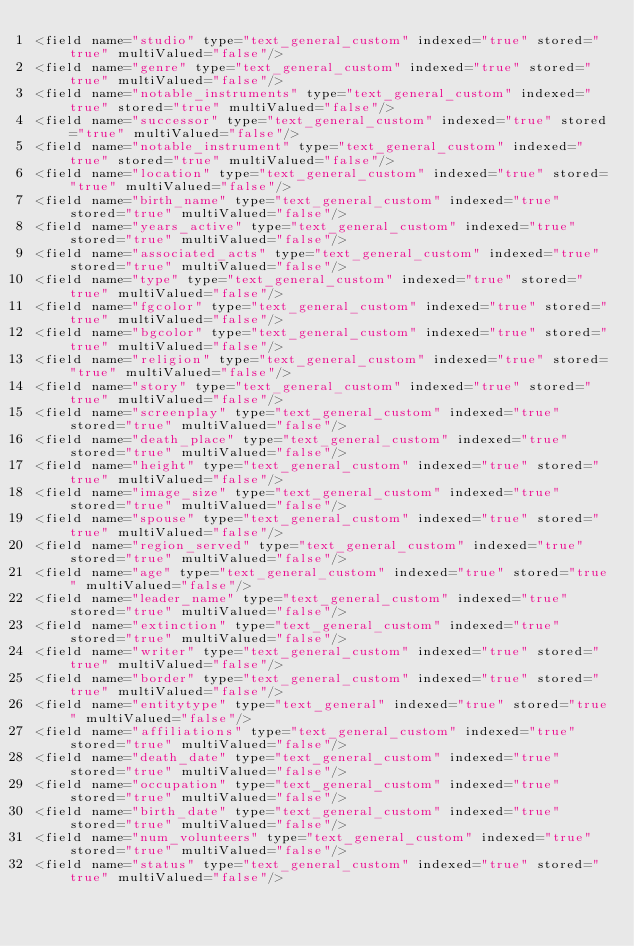Convert code to text. <code><loc_0><loc_0><loc_500><loc_500><_XML_><field name="studio" type="text_general_custom" indexed="true" stored="true" multiValued="false"/>
<field name="genre" type="text_general_custom" indexed="true" stored="true" multiValued="false"/>
<field name="notable_instruments" type="text_general_custom" indexed="true" stored="true" multiValued="false"/>
<field name="successor" type="text_general_custom" indexed="true" stored="true" multiValued="false"/>
<field name="notable_instrument" type="text_general_custom" indexed="true" stored="true" multiValued="false"/>
<field name="location" type="text_general_custom" indexed="true" stored="true" multiValued="false"/>
<field name="birth_name" type="text_general_custom" indexed="true" stored="true" multiValued="false"/>
<field name="years_active" type="text_general_custom" indexed="true" stored="true" multiValued="false"/>
<field name="associated_acts" type="text_general_custom" indexed="true" stored="true" multiValued="false"/>
<field name="type" type="text_general_custom" indexed="true" stored="true" multiValued="false"/>
<field name="fgcolor" type="text_general_custom" indexed="true" stored="true" multiValued="false"/>
<field name="bgcolor" type="text_general_custom" indexed="true" stored="true" multiValued="false"/>
<field name="religion" type="text_general_custom" indexed="true" stored="true" multiValued="false"/>
<field name="story" type="text_general_custom" indexed="true" stored="true" multiValued="false"/>
<field name="screenplay" type="text_general_custom" indexed="true" stored="true" multiValued="false"/>
<field name="death_place" type="text_general_custom" indexed="true" stored="true" multiValued="false"/>
<field name="height" type="text_general_custom" indexed="true" stored="true" multiValued="false"/>
<field name="image_size" type="text_general_custom" indexed="true" stored="true" multiValued="false"/>
<field name="spouse" type="text_general_custom" indexed="true" stored="true" multiValued="false"/>
<field name="region_served" type="text_general_custom" indexed="true" stored="true" multiValued="false"/>
<field name="age" type="text_general_custom" indexed="true" stored="true" multiValued="false"/>
<field name="leader_name" type="text_general_custom" indexed="true" stored="true" multiValued="false"/>
<field name="extinction" type="text_general_custom" indexed="true" stored="true" multiValued="false"/>
<field name="writer" type="text_general_custom" indexed="true" stored="true" multiValued="false"/>
<field name="border" type="text_general_custom" indexed="true" stored="true" multiValued="false"/>
<field name="entitytype" type="text_general" indexed="true" stored="true" multiValued="false"/>
<field name="affiliations" type="text_general_custom" indexed="true" stored="true" multiValued="false"/>
<field name="death_date" type="text_general_custom" indexed="true" stored="true" multiValued="false"/>
<field name="occupation" type="text_general_custom" indexed="true" stored="true" multiValued="false"/>
<field name="birth_date" type="text_general_custom" indexed="true" stored="true" multiValued="false"/>
<field name="num_volunteers" type="text_general_custom" indexed="true" stored="true" multiValued="false"/>
<field name="status" type="text_general_custom" indexed="true" stored="true" multiValued="false"/></code> 